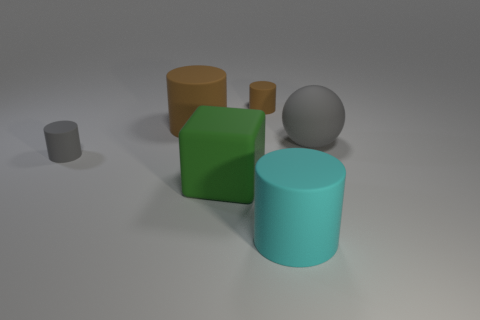What materials seem to be represented in the image? The image showcases objects with various textures that suggest different materials. The green and blue cylinders have a smooth, possibly plastic or metallic finish, indicative of a shiny and reflective material. Meanwhile, the grey sphere has a less reflective, matte surface that could resemble stone or concrete. The small grey cylinder and the orange cube also display a matte finish, possibly representing a non-glossy plastic or painted wood. 